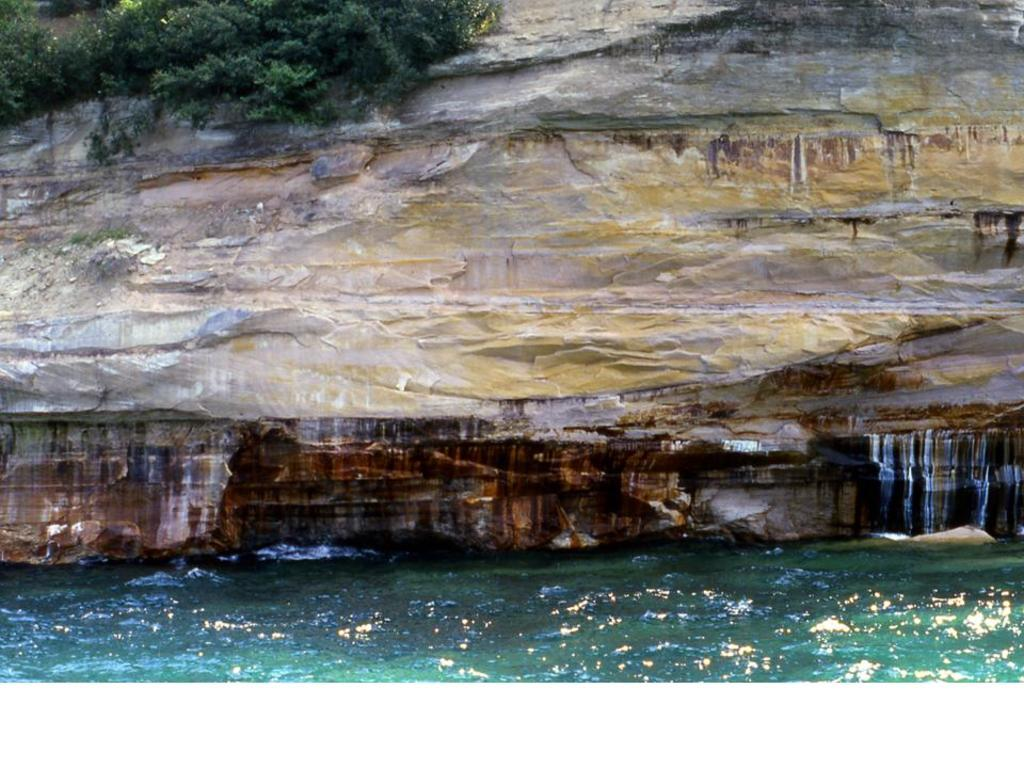What is the primary element visible in the image? There is water in the image. What can be seen in the background of the image? There is a rock wall and trees in the background of the image. How many bubbles are floating on the surface of the water in the image? There are no bubbles visible on the surface of the water in the image. 